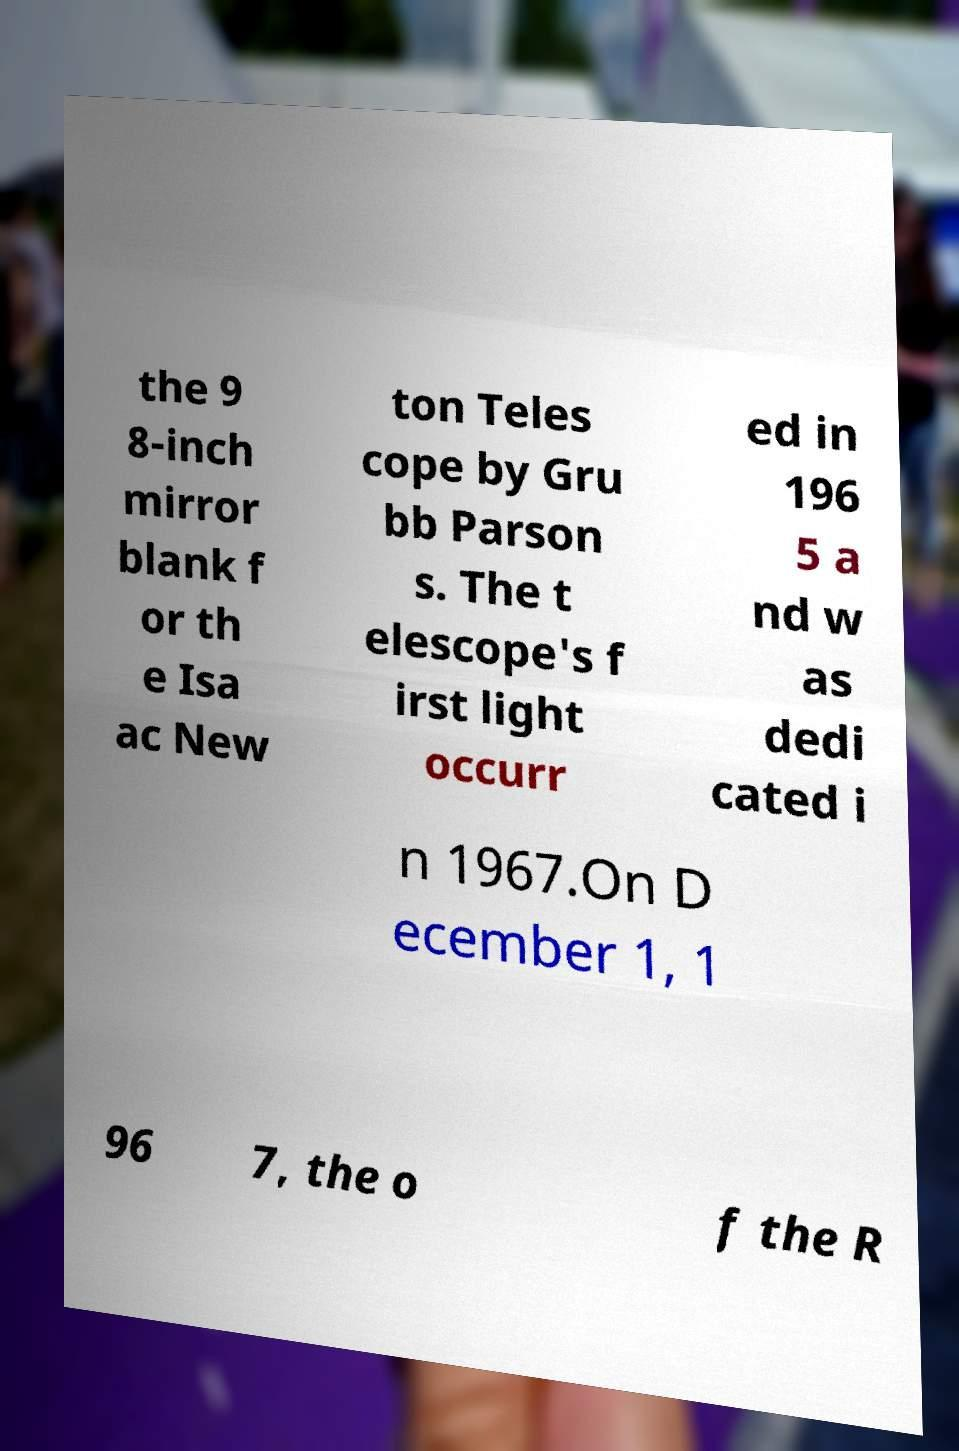What messages or text are displayed in this image? I need them in a readable, typed format. the 9 8-inch mirror blank f or th e Isa ac New ton Teles cope by Gru bb Parson s. The t elescope's f irst light occurr ed in 196 5 a nd w as dedi cated i n 1967.On D ecember 1, 1 96 7, the o f the R 